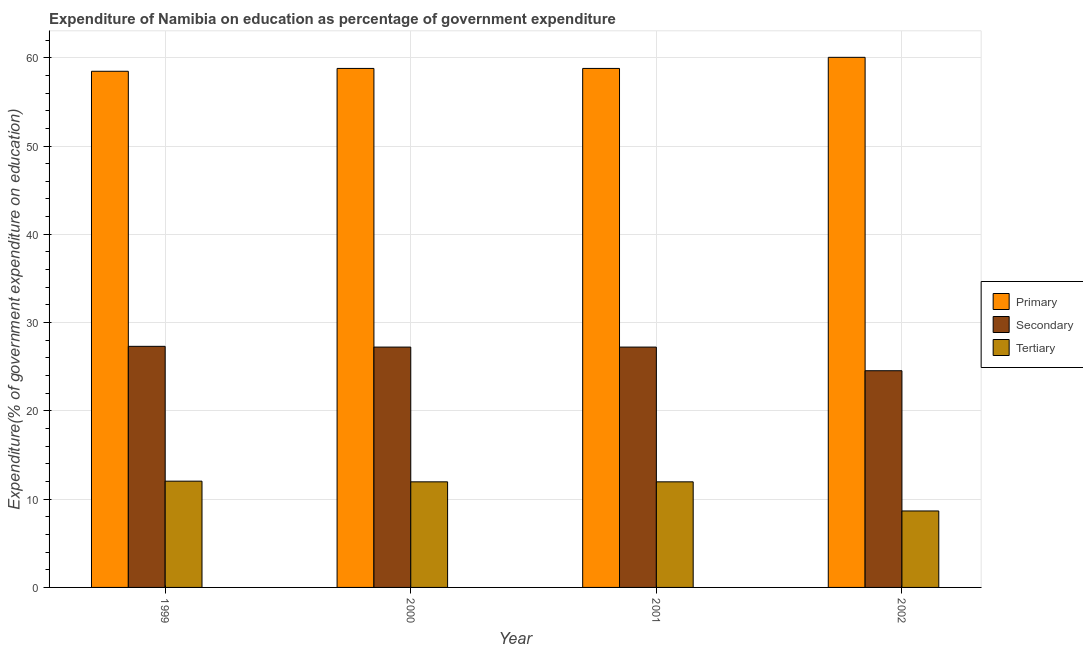How many groups of bars are there?
Your answer should be very brief. 4. Are the number of bars per tick equal to the number of legend labels?
Make the answer very short. Yes. Are the number of bars on each tick of the X-axis equal?
Your answer should be very brief. Yes. How many bars are there on the 1st tick from the right?
Give a very brief answer. 3. What is the expenditure on secondary education in 1999?
Provide a short and direct response. 27.31. Across all years, what is the maximum expenditure on tertiary education?
Keep it short and to the point. 12.04. Across all years, what is the minimum expenditure on primary education?
Your answer should be compact. 58.47. What is the total expenditure on secondary education in the graph?
Provide a succinct answer. 106.3. What is the difference between the expenditure on secondary education in 2000 and that in 2001?
Your response must be concise. 0. What is the difference between the expenditure on tertiary education in 1999 and the expenditure on secondary education in 2001?
Provide a succinct answer. 0.08. What is the average expenditure on tertiary education per year?
Give a very brief answer. 11.16. In how many years, is the expenditure on secondary education greater than 4 %?
Give a very brief answer. 4. What is the ratio of the expenditure on primary education in 2000 to that in 2002?
Keep it short and to the point. 0.98. Is the expenditure on tertiary education in 2001 less than that in 2002?
Your answer should be compact. No. Is the difference between the expenditure on secondary education in 1999 and 2001 greater than the difference between the expenditure on tertiary education in 1999 and 2001?
Keep it short and to the point. No. What is the difference between the highest and the second highest expenditure on primary education?
Your response must be concise. 1.26. What is the difference between the highest and the lowest expenditure on primary education?
Make the answer very short. 1.58. In how many years, is the expenditure on primary education greater than the average expenditure on primary education taken over all years?
Your answer should be compact. 1. Is the sum of the expenditure on primary education in 1999 and 2001 greater than the maximum expenditure on secondary education across all years?
Give a very brief answer. Yes. What does the 1st bar from the left in 2002 represents?
Your response must be concise. Primary. What does the 1st bar from the right in 2001 represents?
Make the answer very short. Tertiary. Is it the case that in every year, the sum of the expenditure on primary education and expenditure on secondary education is greater than the expenditure on tertiary education?
Your answer should be compact. Yes. How many bars are there?
Provide a succinct answer. 12. How many years are there in the graph?
Offer a very short reply. 4. What is the difference between two consecutive major ticks on the Y-axis?
Your response must be concise. 10. Are the values on the major ticks of Y-axis written in scientific E-notation?
Offer a very short reply. No. Does the graph contain grids?
Give a very brief answer. Yes. How are the legend labels stacked?
Make the answer very short. Vertical. What is the title of the graph?
Your response must be concise. Expenditure of Namibia on education as percentage of government expenditure. Does "Liquid fuel" appear as one of the legend labels in the graph?
Keep it short and to the point. No. What is the label or title of the Y-axis?
Provide a succinct answer. Expenditure(% of government expenditure on education). What is the Expenditure(% of government expenditure on education) of Primary in 1999?
Your answer should be compact. 58.47. What is the Expenditure(% of government expenditure on education) in Secondary in 1999?
Offer a terse response. 27.31. What is the Expenditure(% of government expenditure on education) in Tertiary in 1999?
Your answer should be very brief. 12.04. What is the Expenditure(% of government expenditure on education) in Primary in 2000?
Give a very brief answer. 58.79. What is the Expenditure(% of government expenditure on education) of Secondary in 2000?
Provide a succinct answer. 27.22. What is the Expenditure(% of government expenditure on education) in Tertiary in 2000?
Keep it short and to the point. 11.96. What is the Expenditure(% of government expenditure on education) of Primary in 2001?
Offer a terse response. 58.79. What is the Expenditure(% of government expenditure on education) in Secondary in 2001?
Your answer should be very brief. 27.22. What is the Expenditure(% of government expenditure on education) in Tertiary in 2001?
Your answer should be very brief. 11.96. What is the Expenditure(% of government expenditure on education) of Primary in 2002?
Provide a succinct answer. 60.05. What is the Expenditure(% of government expenditure on education) in Secondary in 2002?
Provide a succinct answer. 24.55. What is the Expenditure(% of government expenditure on education) of Tertiary in 2002?
Keep it short and to the point. 8.66. Across all years, what is the maximum Expenditure(% of government expenditure on education) in Primary?
Provide a short and direct response. 60.05. Across all years, what is the maximum Expenditure(% of government expenditure on education) of Secondary?
Your response must be concise. 27.31. Across all years, what is the maximum Expenditure(% of government expenditure on education) of Tertiary?
Provide a short and direct response. 12.04. Across all years, what is the minimum Expenditure(% of government expenditure on education) of Primary?
Provide a succinct answer. 58.47. Across all years, what is the minimum Expenditure(% of government expenditure on education) in Secondary?
Provide a short and direct response. 24.55. Across all years, what is the minimum Expenditure(% of government expenditure on education) of Tertiary?
Provide a short and direct response. 8.66. What is the total Expenditure(% of government expenditure on education) of Primary in the graph?
Provide a short and direct response. 236.09. What is the total Expenditure(% of government expenditure on education) in Secondary in the graph?
Give a very brief answer. 106.3. What is the total Expenditure(% of government expenditure on education) in Tertiary in the graph?
Your answer should be compact. 44.62. What is the difference between the Expenditure(% of government expenditure on education) in Primary in 1999 and that in 2000?
Keep it short and to the point. -0.32. What is the difference between the Expenditure(% of government expenditure on education) in Secondary in 1999 and that in 2000?
Keep it short and to the point. 0.08. What is the difference between the Expenditure(% of government expenditure on education) of Tertiary in 1999 and that in 2000?
Give a very brief answer. 0.08. What is the difference between the Expenditure(% of government expenditure on education) of Primary in 1999 and that in 2001?
Provide a short and direct response. -0.32. What is the difference between the Expenditure(% of government expenditure on education) in Secondary in 1999 and that in 2001?
Provide a short and direct response. 0.08. What is the difference between the Expenditure(% of government expenditure on education) of Tertiary in 1999 and that in 2001?
Your answer should be very brief. 0.08. What is the difference between the Expenditure(% of government expenditure on education) in Primary in 1999 and that in 2002?
Your response must be concise. -1.58. What is the difference between the Expenditure(% of government expenditure on education) of Secondary in 1999 and that in 2002?
Ensure brevity in your answer.  2.76. What is the difference between the Expenditure(% of government expenditure on education) of Tertiary in 1999 and that in 2002?
Your answer should be compact. 3.38. What is the difference between the Expenditure(% of government expenditure on education) in Primary in 2000 and that in 2001?
Offer a terse response. 0. What is the difference between the Expenditure(% of government expenditure on education) of Secondary in 2000 and that in 2001?
Your response must be concise. 0. What is the difference between the Expenditure(% of government expenditure on education) in Primary in 2000 and that in 2002?
Provide a short and direct response. -1.26. What is the difference between the Expenditure(% of government expenditure on education) of Secondary in 2000 and that in 2002?
Ensure brevity in your answer.  2.68. What is the difference between the Expenditure(% of government expenditure on education) in Tertiary in 2000 and that in 2002?
Your answer should be very brief. 3.3. What is the difference between the Expenditure(% of government expenditure on education) in Primary in 2001 and that in 2002?
Give a very brief answer. -1.26. What is the difference between the Expenditure(% of government expenditure on education) of Secondary in 2001 and that in 2002?
Your answer should be very brief. 2.68. What is the difference between the Expenditure(% of government expenditure on education) in Tertiary in 2001 and that in 2002?
Make the answer very short. 3.3. What is the difference between the Expenditure(% of government expenditure on education) of Primary in 1999 and the Expenditure(% of government expenditure on education) of Secondary in 2000?
Provide a short and direct response. 31.24. What is the difference between the Expenditure(% of government expenditure on education) in Primary in 1999 and the Expenditure(% of government expenditure on education) in Tertiary in 2000?
Offer a very short reply. 46.51. What is the difference between the Expenditure(% of government expenditure on education) of Secondary in 1999 and the Expenditure(% of government expenditure on education) of Tertiary in 2000?
Provide a short and direct response. 15.35. What is the difference between the Expenditure(% of government expenditure on education) in Primary in 1999 and the Expenditure(% of government expenditure on education) in Secondary in 2001?
Make the answer very short. 31.24. What is the difference between the Expenditure(% of government expenditure on education) in Primary in 1999 and the Expenditure(% of government expenditure on education) in Tertiary in 2001?
Provide a short and direct response. 46.51. What is the difference between the Expenditure(% of government expenditure on education) of Secondary in 1999 and the Expenditure(% of government expenditure on education) of Tertiary in 2001?
Provide a short and direct response. 15.35. What is the difference between the Expenditure(% of government expenditure on education) of Primary in 1999 and the Expenditure(% of government expenditure on education) of Secondary in 2002?
Keep it short and to the point. 33.92. What is the difference between the Expenditure(% of government expenditure on education) of Primary in 1999 and the Expenditure(% of government expenditure on education) of Tertiary in 2002?
Offer a terse response. 49.8. What is the difference between the Expenditure(% of government expenditure on education) of Secondary in 1999 and the Expenditure(% of government expenditure on education) of Tertiary in 2002?
Your answer should be very brief. 18.65. What is the difference between the Expenditure(% of government expenditure on education) in Primary in 2000 and the Expenditure(% of government expenditure on education) in Secondary in 2001?
Offer a very short reply. 31.56. What is the difference between the Expenditure(% of government expenditure on education) of Primary in 2000 and the Expenditure(% of government expenditure on education) of Tertiary in 2001?
Provide a short and direct response. 46.83. What is the difference between the Expenditure(% of government expenditure on education) in Secondary in 2000 and the Expenditure(% of government expenditure on education) in Tertiary in 2001?
Your answer should be compact. 15.26. What is the difference between the Expenditure(% of government expenditure on education) in Primary in 2000 and the Expenditure(% of government expenditure on education) in Secondary in 2002?
Provide a short and direct response. 34.24. What is the difference between the Expenditure(% of government expenditure on education) of Primary in 2000 and the Expenditure(% of government expenditure on education) of Tertiary in 2002?
Your response must be concise. 50.13. What is the difference between the Expenditure(% of government expenditure on education) of Secondary in 2000 and the Expenditure(% of government expenditure on education) of Tertiary in 2002?
Offer a very short reply. 18.56. What is the difference between the Expenditure(% of government expenditure on education) of Primary in 2001 and the Expenditure(% of government expenditure on education) of Secondary in 2002?
Provide a succinct answer. 34.24. What is the difference between the Expenditure(% of government expenditure on education) in Primary in 2001 and the Expenditure(% of government expenditure on education) in Tertiary in 2002?
Your answer should be very brief. 50.13. What is the difference between the Expenditure(% of government expenditure on education) in Secondary in 2001 and the Expenditure(% of government expenditure on education) in Tertiary in 2002?
Your answer should be compact. 18.56. What is the average Expenditure(% of government expenditure on education) in Primary per year?
Provide a short and direct response. 59.02. What is the average Expenditure(% of government expenditure on education) in Secondary per year?
Ensure brevity in your answer.  26.58. What is the average Expenditure(% of government expenditure on education) in Tertiary per year?
Offer a very short reply. 11.16. In the year 1999, what is the difference between the Expenditure(% of government expenditure on education) in Primary and Expenditure(% of government expenditure on education) in Secondary?
Provide a succinct answer. 31.16. In the year 1999, what is the difference between the Expenditure(% of government expenditure on education) of Primary and Expenditure(% of government expenditure on education) of Tertiary?
Offer a very short reply. 46.43. In the year 1999, what is the difference between the Expenditure(% of government expenditure on education) of Secondary and Expenditure(% of government expenditure on education) of Tertiary?
Make the answer very short. 15.27. In the year 2000, what is the difference between the Expenditure(% of government expenditure on education) in Primary and Expenditure(% of government expenditure on education) in Secondary?
Your answer should be compact. 31.56. In the year 2000, what is the difference between the Expenditure(% of government expenditure on education) in Primary and Expenditure(% of government expenditure on education) in Tertiary?
Your answer should be very brief. 46.83. In the year 2000, what is the difference between the Expenditure(% of government expenditure on education) of Secondary and Expenditure(% of government expenditure on education) of Tertiary?
Offer a terse response. 15.26. In the year 2001, what is the difference between the Expenditure(% of government expenditure on education) in Primary and Expenditure(% of government expenditure on education) in Secondary?
Keep it short and to the point. 31.56. In the year 2001, what is the difference between the Expenditure(% of government expenditure on education) in Primary and Expenditure(% of government expenditure on education) in Tertiary?
Your answer should be very brief. 46.83. In the year 2001, what is the difference between the Expenditure(% of government expenditure on education) of Secondary and Expenditure(% of government expenditure on education) of Tertiary?
Provide a succinct answer. 15.26. In the year 2002, what is the difference between the Expenditure(% of government expenditure on education) of Primary and Expenditure(% of government expenditure on education) of Secondary?
Give a very brief answer. 35.5. In the year 2002, what is the difference between the Expenditure(% of government expenditure on education) of Primary and Expenditure(% of government expenditure on education) of Tertiary?
Offer a very short reply. 51.38. In the year 2002, what is the difference between the Expenditure(% of government expenditure on education) of Secondary and Expenditure(% of government expenditure on education) of Tertiary?
Keep it short and to the point. 15.88. What is the ratio of the Expenditure(% of government expenditure on education) in Primary in 1999 to that in 2000?
Give a very brief answer. 0.99. What is the ratio of the Expenditure(% of government expenditure on education) of Secondary in 1999 to that in 2000?
Provide a short and direct response. 1. What is the ratio of the Expenditure(% of government expenditure on education) of Tertiary in 1999 to that in 2000?
Keep it short and to the point. 1.01. What is the ratio of the Expenditure(% of government expenditure on education) of Tertiary in 1999 to that in 2001?
Offer a very short reply. 1.01. What is the ratio of the Expenditure(% of government expenditure on education) of Primary in 1999 to that in 2002?
Offer a very short reply. 0.97. What is the ratio of the Expenditure(% of government expenditure on education) of Secondary in 1999 to that in 2002?
Offer a terse response. 1.11. What is the ratio of the Expenditure(% of government expenditure on education) in Tertiary in 1999 to that in 2002?
Give a very brief answer. 1.39. What is the ratio of the Expenditure(% of government expenditure on education) of Primary in 2000 to that in 2001?
Make the answer very short. 1. What is the ratio of the Expenditure(% of government expenditure on education) of Primary in 2000 to that in 2002?
Your response must be concise. 0.98. What is the ratio of the Expenditure(% of government expenditure on education) of Secondary in 2000 to that in 2002?
Give a very brief answer. 1.11. What is the ratio of the Expenditure(% of government expenditure on education) of Tertiary in 2000 to that in 2002?
Give a very brief answer. 1.38. What is the ratio of the Expenditure(% of government expenditure on education) of Secondary in 2001 to that in 2002?
Your answer should be very brief. 1.11. What is the ratio of the Expenditure(% of government expenditure on education) in Tertiary in 2001 to that in 2002?
Your answer should be very brief. 1.38. What is the difference between the highest and the second highest Expenditure(% of government expenditure on education) in Primary?
Your response must be concise. 1.26. What is the difference between the highest and the second highest Expenditure(% of government expenditure on education) of Secondary?
Provide a succinct answer. 0.08. What is the difference between the highest and the second highest Expenditure(% of government expenditure on education) in Tertiary?
Keep it short and to the point. 0.08. What is the difference between the highest and the lowest Expenditure(% of government expenditure on education) of Primary?
Your answer should be compact. 1.58. What is the difference between the highest and the lowest Expenditure(% of government expenditure on education) in Secondary?
Give a very brief answer. 2.76. What is the difference between the highest and the lowest Expenditure(% of government expenditure on education) in Tertiary?
Ensure brevity in your answer.  3.38. 